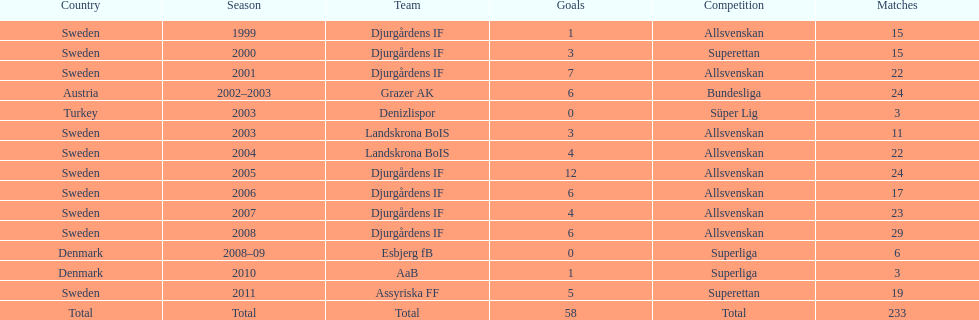What season has the most goals? 2005. 